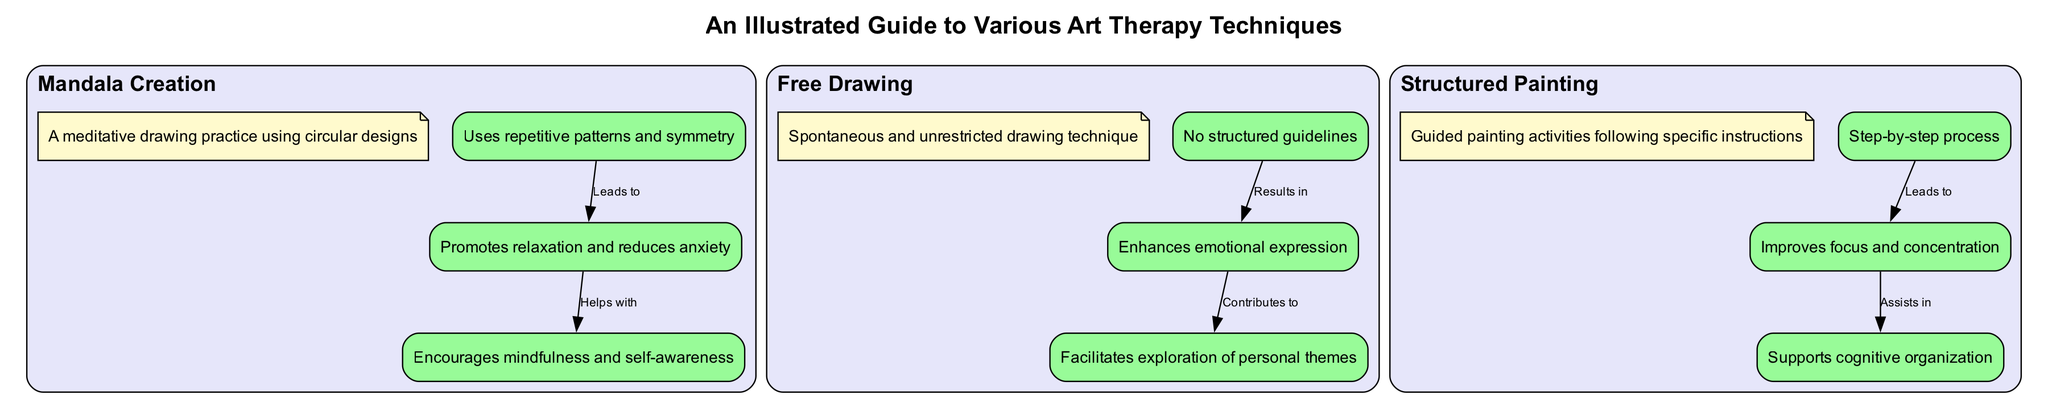What are the benefits of Mandala Creation? The diagram shows that the benefits of Mandala Creation include "Promotes relaxation and reduces anxiety." This information is found in the node labeled "Mandala_Benefits."
Answer: Promotes relaxation and reduces anxiety How many primary art therapy techniques are illustrated? The diagram has three main sections, which correspond to three primary techniques: Mandala Creation, Free Drawing, and Structured Painting.
Answer: Three What leads to improved focus and concentration in Structured Painting? The diagram indicates that "Step-by-step process" leads to "Improves focus and concentration," as shown in the connection between those two nodes.
Answer: Step-by-step process What does Free Drawing facilitate for individuals with schizophrenia? The diagram states that Free Drawing "Facilitates exploration of personal themes," shown in the node labeled "Schizophrenia_Benefits_Free_Drawing."
Answer: Facilitates exploration of personal themes What element is associated with mandalas to help with schizophrenia? The diagram shows that "Mandala_Benefits" helps with "Encourages mindfulness and self-awareness," which relates to the therapeutic benefits of using mandalas for individuals with schizophrenia.
Answer: Encourages mindfulness and self-awareness What is the primary element in Free Drawing that results in emotional expression? The diagram highlights that "No structured guidelines" is the primary element in Free Drawing that results in "Enhances emotional expression." This is shown in the connection between these nodes.
Answer: No structured guidelines What type of art therapy technique improves cognitive organization? The diagram specifies that "Structured Painting" has the benefit of improving cognitive organization as indicated in the node "Schizophrenia_Benefits_Structured_Painting."
Answer: Structured Painting What promotes relaxation in Mandala Creation? The connection in the diagram indicates that "Uses repetitive patterns and symmetry" promotes "Relaxation" which is indicated as a benefit of Mandala Creation.
Answer: Uses repetitive patterns and symmetry 